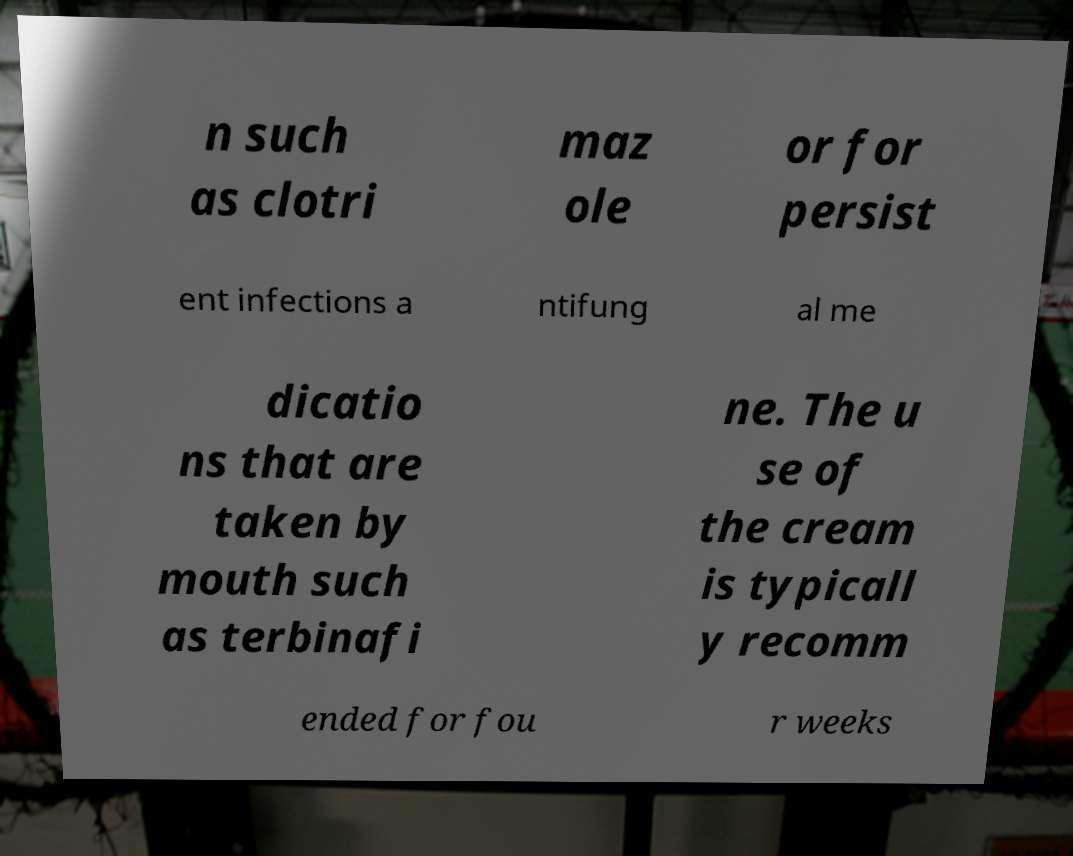Could you assist in decoding the text presented in this image and type it out clearly? n such as clotri maz ole or for persist ent infections a ntifung al me dicatio ns that are taken by mouth such as terbinafi ne. The u se of the cream is typicall y recomm ended for fou r weeks 